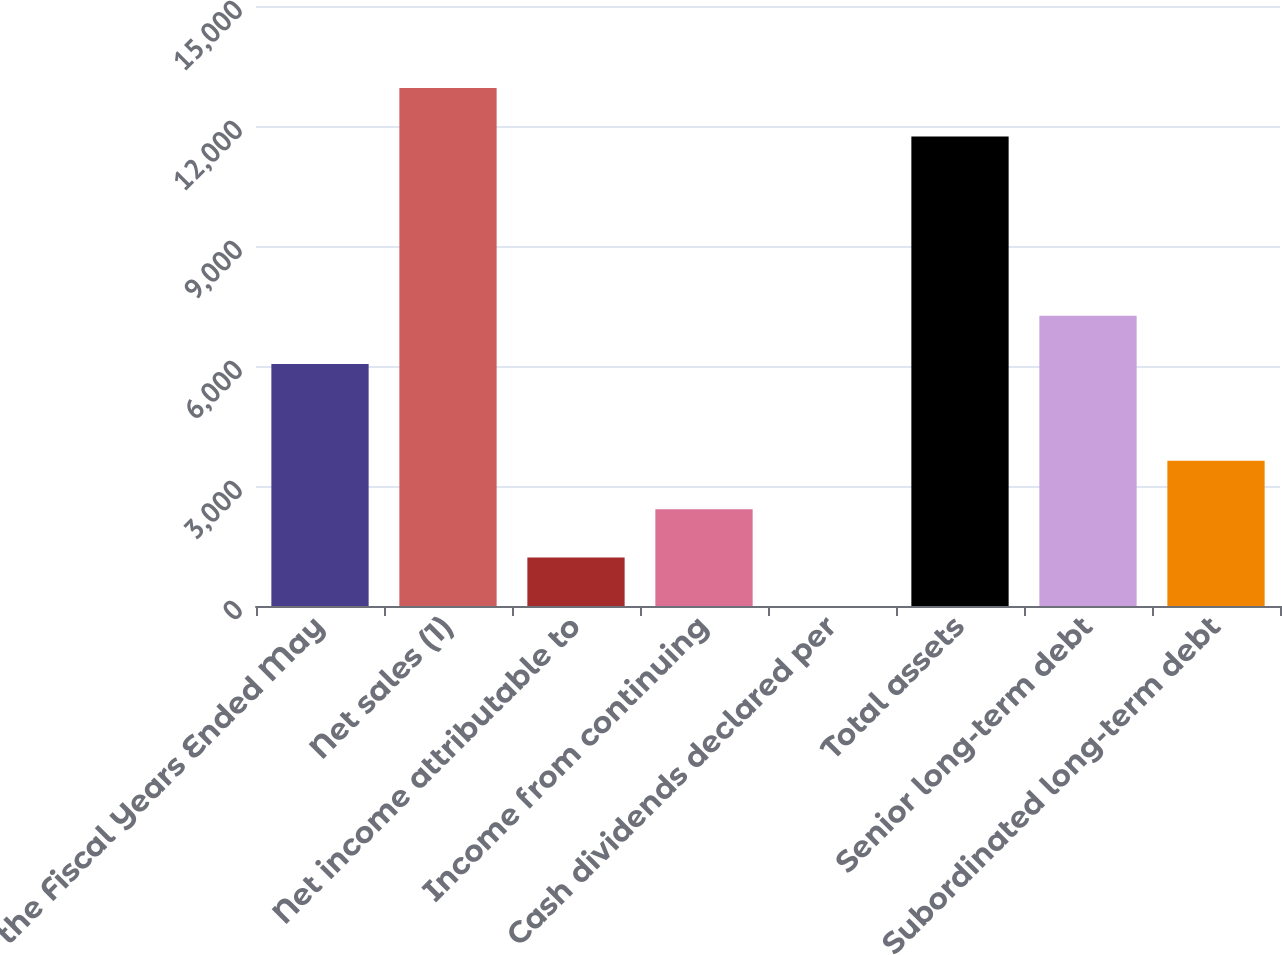Convert chart. <chart><loc_0><loc_0><loc_500><loc_500><bar_chart><fcel>For the Fiscal Years Ended May<fcel>Net sales (1)<fcel>Net income attributable to<fcel>Income from continuing<fcel>Cash dividends declared per<fcel>Total assets<fcel>Senior long-term debt<fcel>Subordinated long-term debt<nl><fcel>6048.79<fcel>12947.6<fcel>1210.39<fcel>2419.99<fcel>0.79<fcel>11738<fcel>7258.39<fcel>3629.59<nl></chart> 